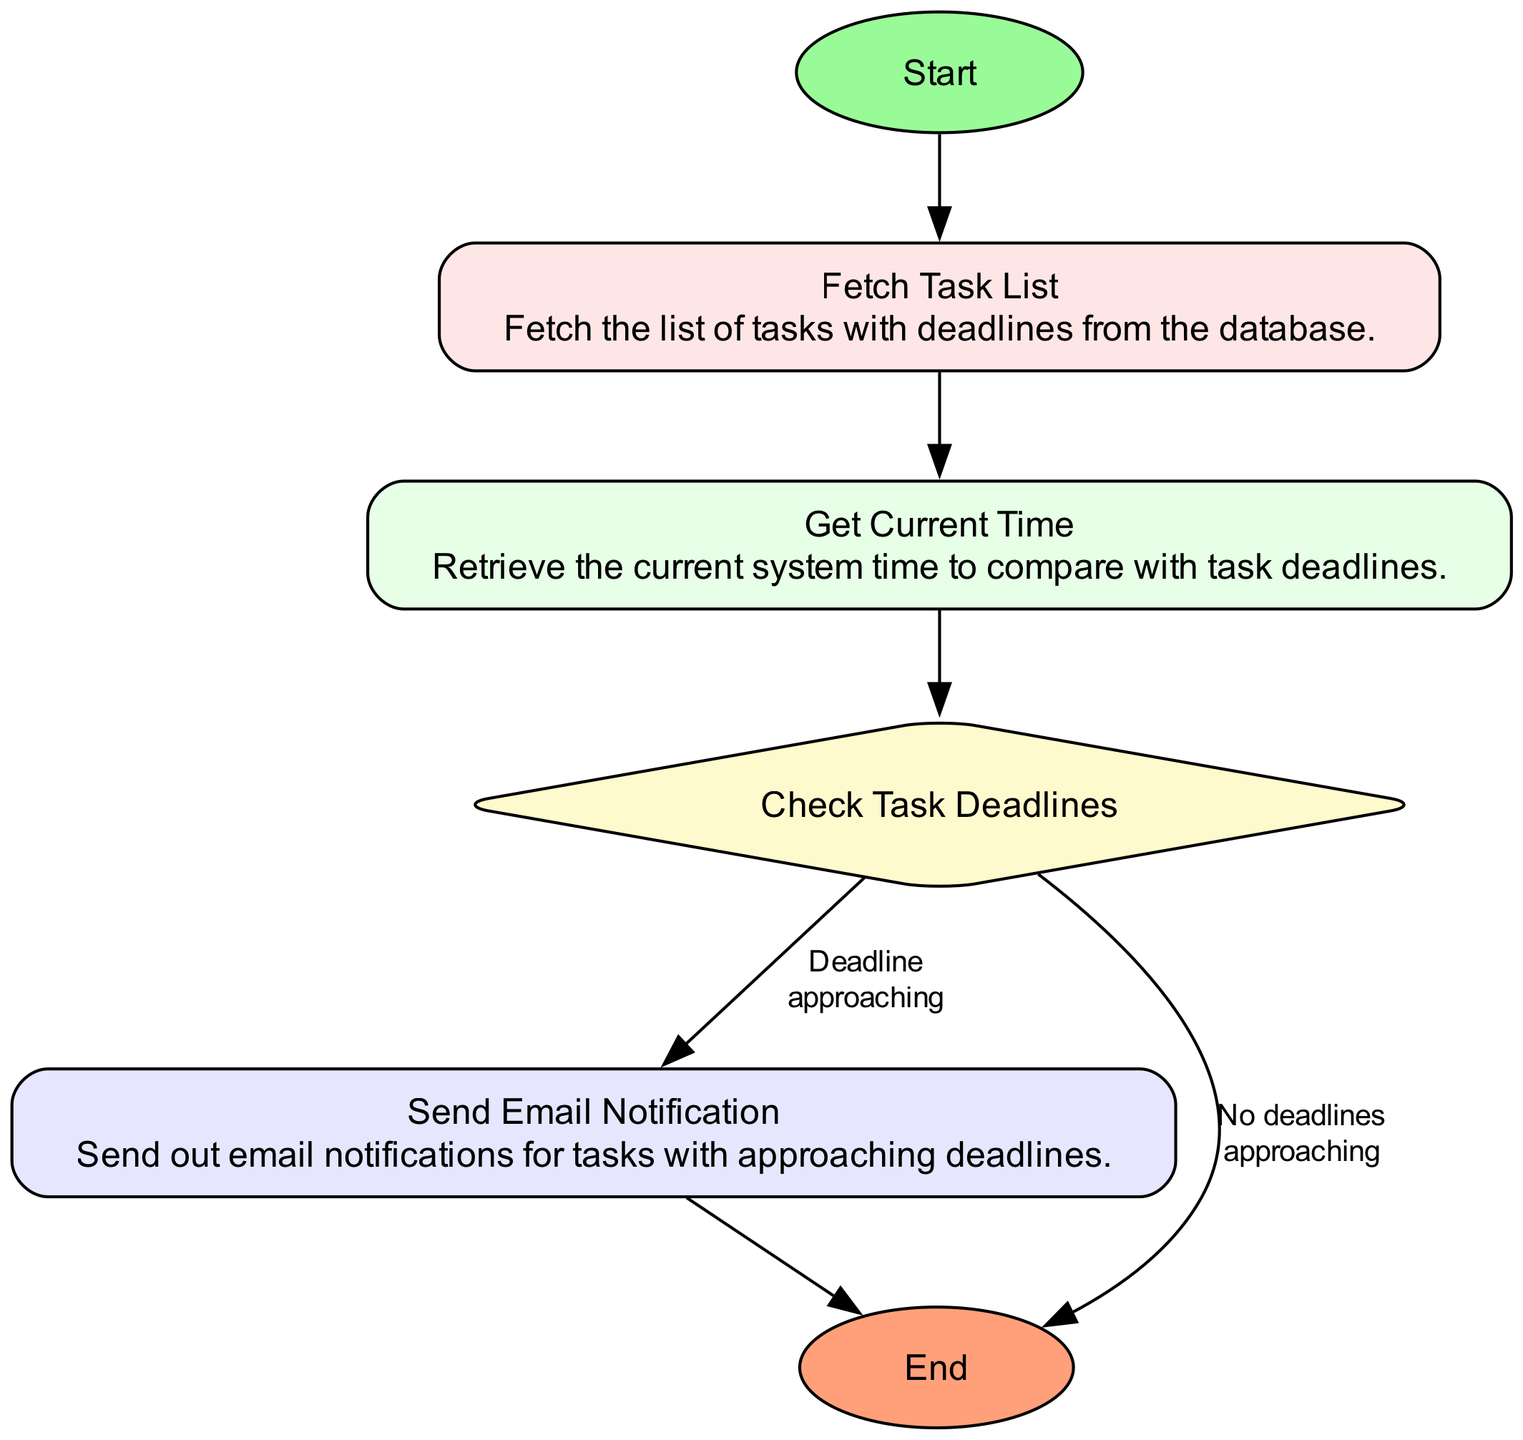What is the first step in the flowchart? The first step in the flowchart is represented by the "Start" node, which initiates the process.
Answer: Start How many tasks are there in the diagram? The diagram contains four tasks: "Fetch Task List," "Get Current Time," "Send Email Notification," and one gateway node.
Answer: Four tasks What happens after "Fetch Task List"? After "Fetch Task List," the next step is "Get Current Time," indicating that the flowchart progresses sequentially from one task to the next.
Answer: Get Current Time What is the relationship between "Check Task Deadlines" and "Send Email Notification"? "Check Task Deadlines" controls the flow to "Send Email Notification" only if there are approaching deadlines, indicating a conditional relationship based on the deadlines' status.
Answer: Conditional relationship What is the color of the "End" node? The "End" node is represented in a salmon color, which differentiates it from other nodes and indicates the conclusion of the process.
Answer: Salmon color What type of node is "Check Task Deadlines"? "Check Task Deadlines" is a gateway node, representing a decision point in the flowchart where the process branches based on conditions.
Answer: Gateway node How does the flow proceed if no deadlines are approaching? If no deadlines are approaching, the flow proceeds from "Check Task Deadlines" directly to "End," bypassing the email notification step.
Answer: Directly to "End" Which task is performed last in the flowchart? The last task performed before reaching the "End" node is "Send Email Notification," indicating that notifications are the final action in this process.
Answer: Send Email Notification 